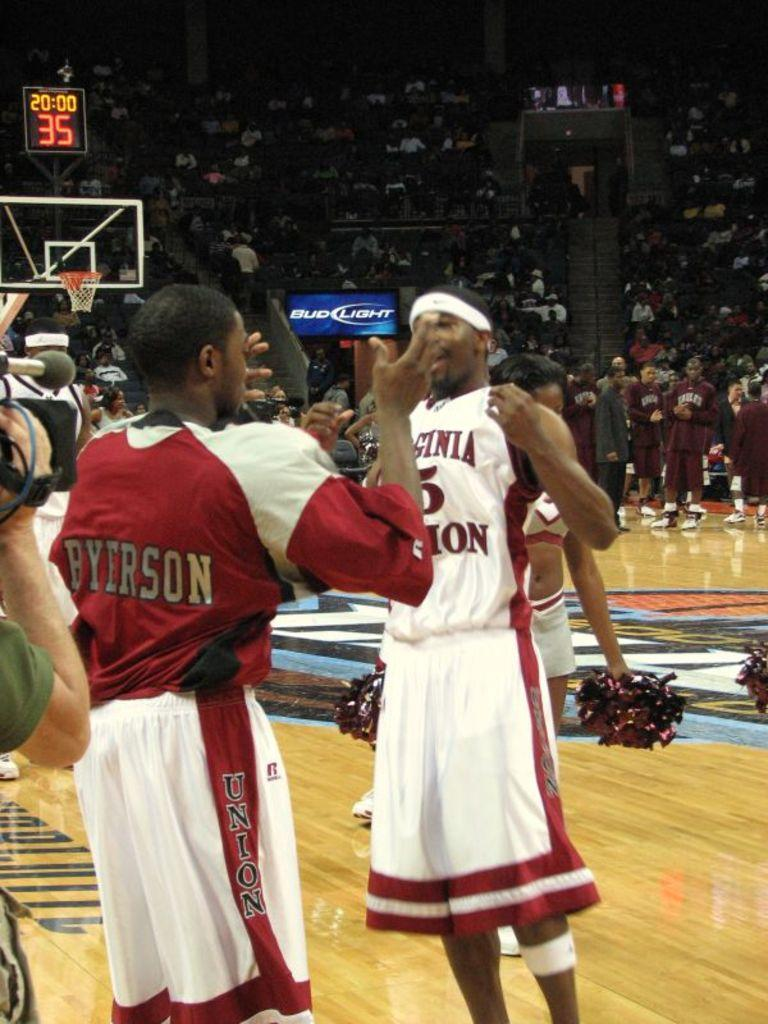What are the people in the image doing? There is a group of people standing on the floor. What are the people wearing? The people are wearing uniforms. What can be seen in the background of the image? There is a group of audience, a clock, and a cameraman in the background. What sort of effect does the stranger have on the group of people in the image? There is no stranger present in the image, so it is not possible to determine any effect they might have on the group of people. 